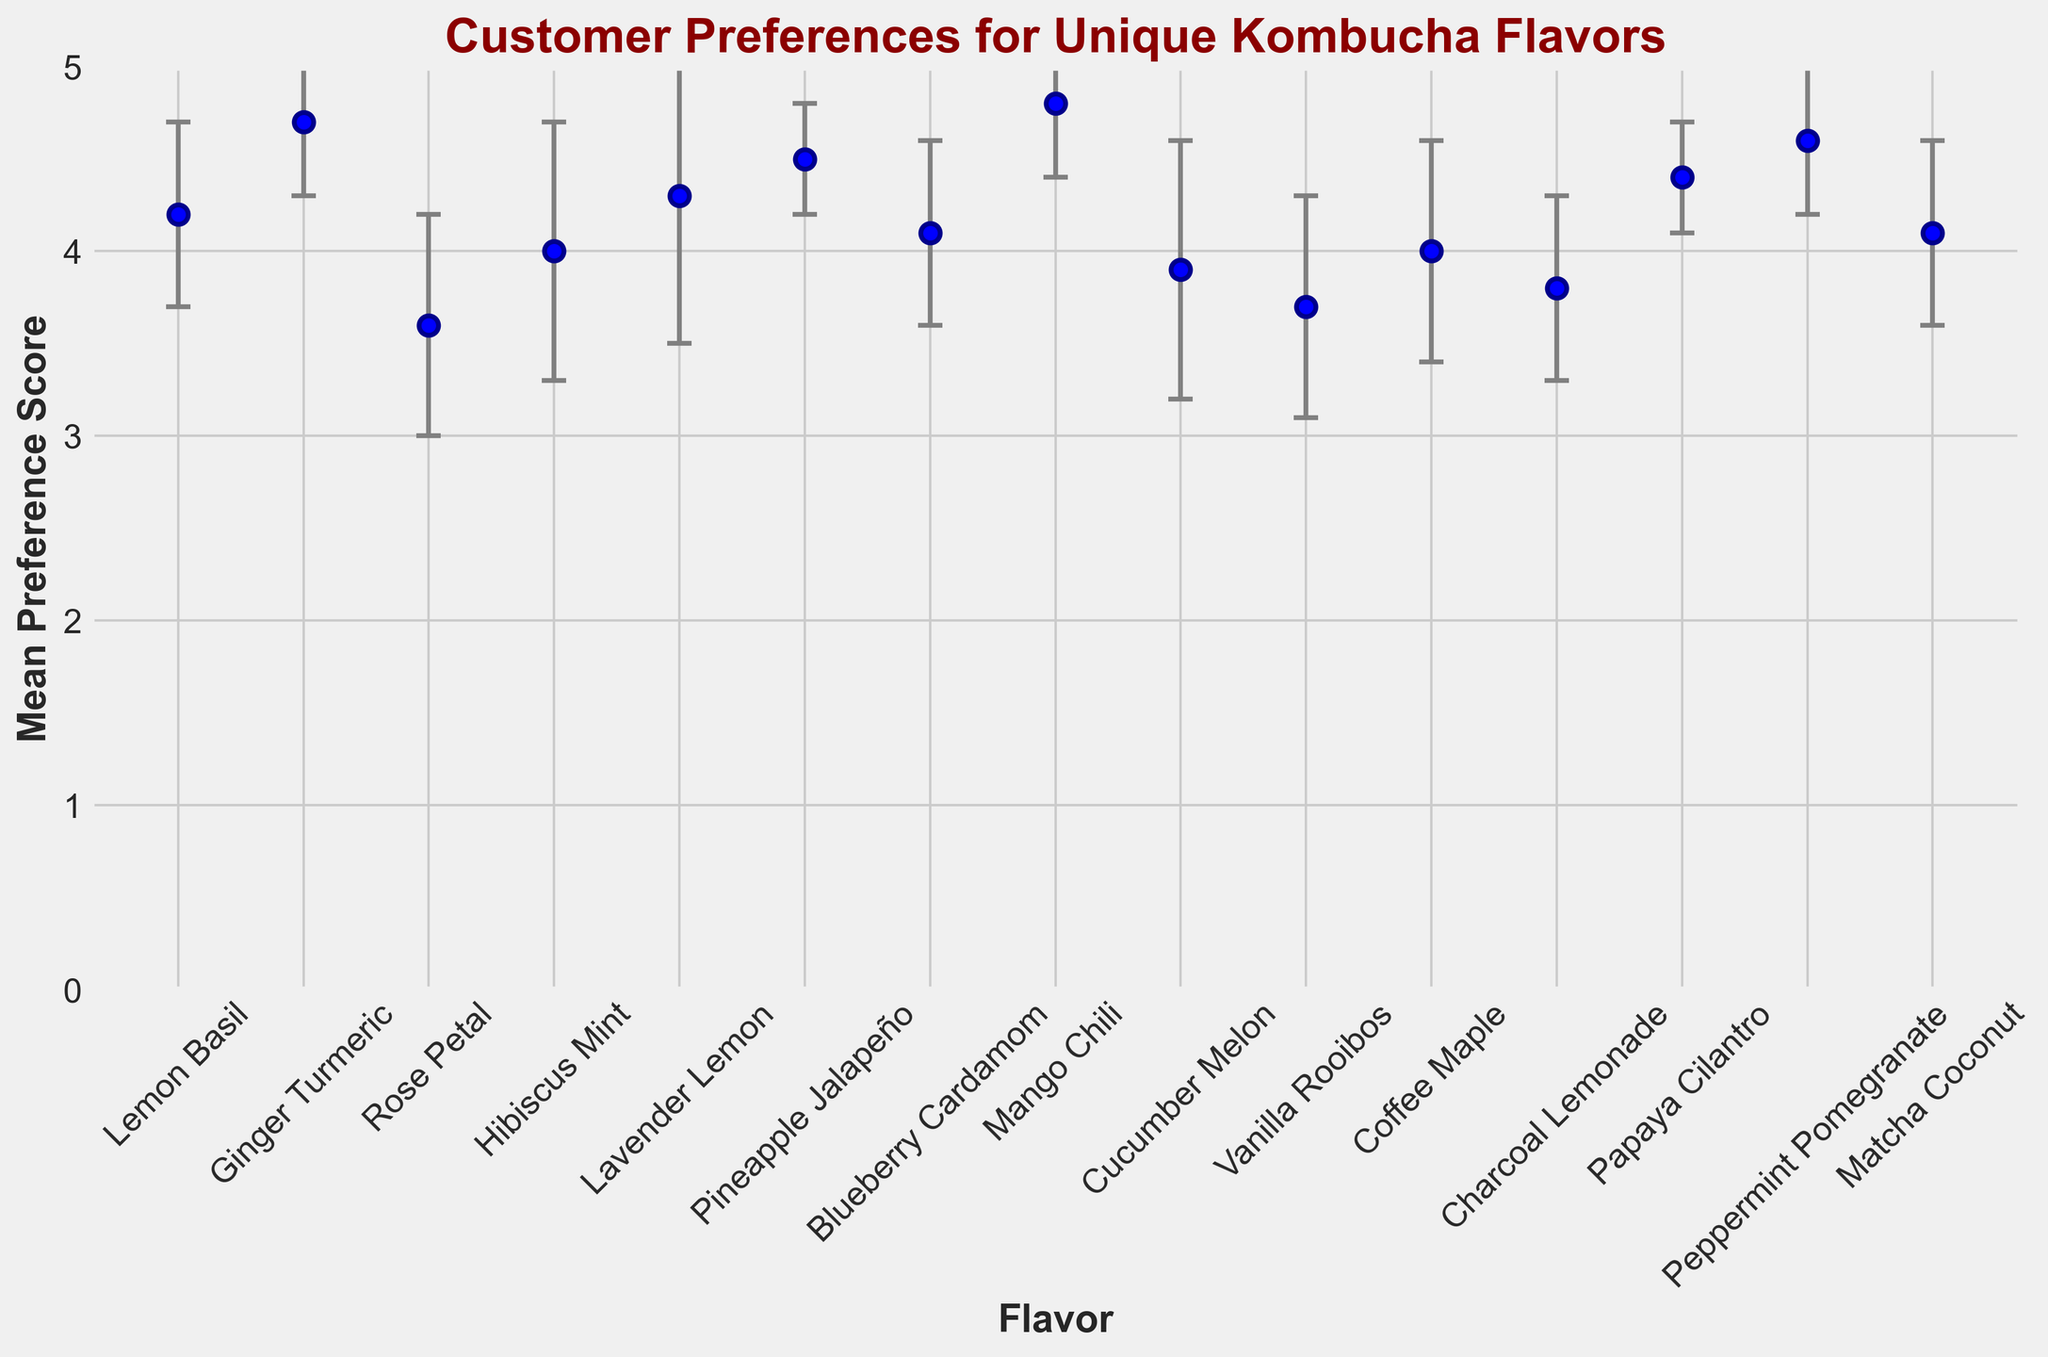Which flavor has the highest mean preference score? By examining the heights of the markers on the plot, we can see which one reaches the highest point on the y-axis. The Mango Chili flavor has the highest mean preference score.
Answer: Mango Chili What is the difference in the mean preference score between the Lemon Basil and Rose Petal flavors? Referencing the y-axis values for Lemon Basil and Rose Petal flavors, the mean preference scores are 4.2 and 3.6, respectively. The difference is calculated as 4.2 - 3.6 = 0.6.
Answer: 0.6 Which flavor has the largest standard deviation? The standard deviation is depicted by the size of the error bars on the figure. The flavor Lavender Lemon has the largest standard deviation as its error bars are the longest.
Answer: Lavender Lemon Which two flavors have the closest mean preference scores? By visually comparing the proximity of the markers along the y-axis, the Hibiscus Mint and Coffee Maple flavors have the closest mean preference scores, both near the 4.0 mark.
Answer: Hibiscus Mint and Coffee Maple What can you say about the consistency of the Pineapple Jalapeño preference score compared to the other flavors? Consistency is indicated by the length of the error bars. Shorter error bars suggest less variability. Pineapple Jalapeño has one of the shortest error bars, indicating a more consistent preference score.
Answer: More consistent How many flavors have a mean preference score of 4.0 or higher? By counting the number of markers at or above the 4.0 line on the y-axis, we can see there are nine flavors with mean preference scores of 4.0 or higher.
Answer: 9 What is the average mean preference score of the top three flavors? The top three flavors based on the highest mean preference scores are Mango Chili (4.8), Ginger Turmeric (4.7), and Peppermint Pomegranate (4.6). The average is calculated as (4.8 + 4.7 + 4.6) / 3 = 4.7.
Answer: 4.7 Which flavor has a higher mean preference score, Cucumber Melon or Vanilla Rooibos? By comparing the heights of the markers, it is evident that Cucumber Melon (3.9) has a higher mean preference score compared to Vanilla Rooibos (3.7).
Answer: Cucumber Melon What is the mean preference score range of the flavors shown in the figure? The range is determined by subtracting the lowest mean preference score from the highest mean preference score in the data. The lowest is Rose Petal (3.6) and the highest is Mango Chili (4.8). Hence, the range is 4.8 - 3.6 = 1.2.
Answer: 1.2 Which flavor having a mean score above 4.0 has the smallest standard deviation? By checking the flavors above the 4.0 mark and observing their error bars, Pineapple Jalapeño has the smallest standard deviation.
Answer: Pineapple Jalapeño 